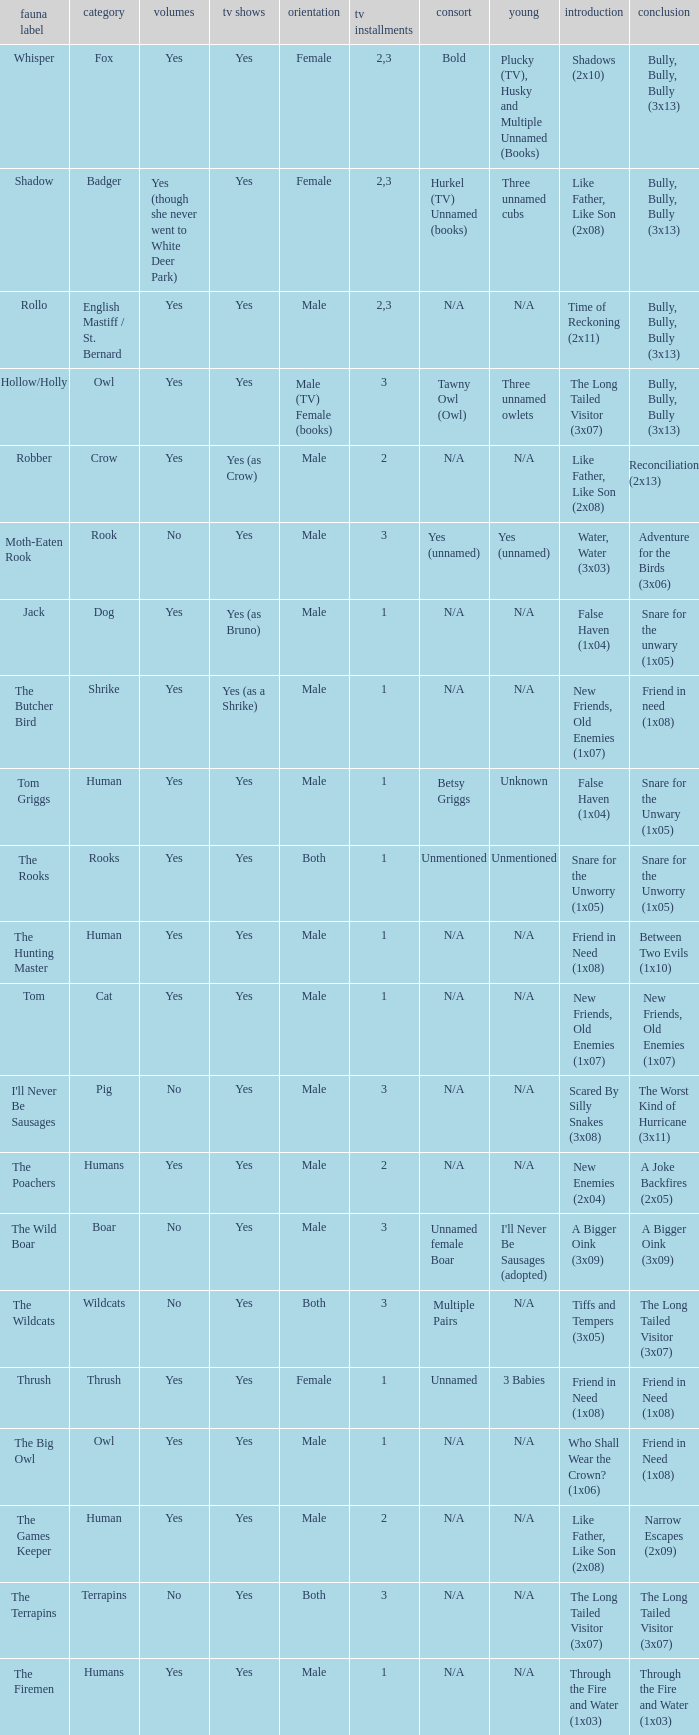What animal was yes for tv series and was a terrapins? The Terrapins. Write the full table. {'header': ['fauna label', 'category', 'volumes', 'tv shows', 'orientation', 'tv installments', 'consort', 'young', 'introduction', 'conclusion'], 'rows': [['Whisper', 'Fox', 'Yes', 'Yes', 'Female', '2,3', 'Bold', 'Plucky (TV), Husky and Multiple Unnamed (Books)', 'Shadows (2x10)', 'Bully, Bully, Bully (3x13)'], ['Shadow', 'Badger', 'Yes (though she never went to White Deer Park)', 'Yes', 'Female', '2,3', 'Hurkel (TV) Unnamed (books)', 'Three unnamed cubs', 'Like Father, Like Son (2x08)', 'Bully, Bully, Bully (3x13)'], ['Rollo', 'English Mastiff / St. Bernard', 'Yes', 'Yes', 'Male', '2,3', 'N/A', 'N/A', 'Time of Reckoning (2x11)', 'Bully, Bully, Bully (3x13)'], ['Hollow/Holly', 'Owl', 'Yes', 'Yes', 'Male (TV) Female (books)', '3', 'Tawny Owl (Owl)', 'Three unnamed owlets', 'The Long Tailed Visitor (3x07)', 'Bully, Bully, Bully (3x13)'], ['Robber', 'Crow', 'Yes', 'Yes (as Crow)', 'Male', '2', 'N/A', 'N/A', 'Like Father, Like Son (2x08)', 'Reconciliation (2x13)'], ['Moth-Eaten Rook', 'Rook', 'No', 'Yes', 'Male', '3', 'Yes (unnamed)', 'Yes (unnamed)', 'Water, Water (3x03)', 'Adventure for the Birds (3x06)'], ['Jack', 'Dog', 'Yes', 'Yes (as Bruno)', 'Male', '1', 'N/A', 'N/A', 'False Haven (1x04)', 'Snare for the unwary (1x05)'], ['The Butcher Bird', 'Shrike', 'Yes', 'Yes (as a Shrike)', 'Male', '1', 'N/A', 'N/A', 'New Friends, Old Enemies (1x07)', 'Friend in need (1x08)'], ['Tom Griggs', 'Human', 'Yes', 'Yes', 'Male', '1', 'Betsy Griggs', 'Unknown', 'False Haven (1x04)', 'Snare for the Unwary (1x05)'], ['The Rooks', 'Rooks', 'Yes', 'Yes', 'Both', '1', 'Unmentioned', 'Unmentioned', 'Snare for the Unworry (1x05)', 'Snare for the Unworry (1x05)'], ['The Hunting Master', 'Human', 'Yes', 'Yes', 'Male', '1', 'N/A', 'N/A', 'Friend in Need (1x08)', 'Between Two Evils (1x10)'], ['Tom', 'Cat', 'Yes', 'Yes', 'Male', '1', 'N/A', 'N/A', 'New Friends, Old Enemies (1x07)', 'New Friends, Old Enemies (1x07)'], ["I'll Never Be Sausages", 'Pig', 'No', 'Yes', 'Male', '3', 'N/A', 'N/A', 'Scared By Silly Snakes (3x08)', 'The Worst Kind of Hurricane (3x11)'], ['The Poachers', 'Humans', 'Yes', 'Yes', 'Male', '2', 'N/A', 'N/A', 'New Enemies (2x04)', 'A Joke Backfires (2x05)'], ['The Wild Boar', 'Boar', 'No', 'Yes', 'Male', '3', 'Unnamed female Boar', "I'll Never Be Sausages (adopted)", 'A Bigger Oink (3x09)', 'A Bigger Oink (3x09)'], ['The Wildcats', 'Wildcats', 'No', 'Yes', 'Both', '3', 'Multiple Pairs', 'N/A', 'Tiffs and Tempers (3x05)', 'The Long Tailed Visitor (3x07)'], ['Thrush', 'Thrush', 'Yes', 'Yes', 'Female', '1', 'Unnamed', '3 Babies', 'Friend in Need (1x08)', 'Friend in Need (1x08)'], ['The Big Owl', 'Owl', 'Yes', 'Yes', 'Male', '1', 'N/A', 'N/A', 'Who Shall Wear the Crown? (1x06)', 'Friend in Need (1x08)'], ['The Games Keeper', 'Human', 'Yes', 'Yes', 'Male', '2', 'N/A', 'N/A', 'Like Father, Like Son (2x08)', 'Narrow Escapes (2x09)'], ['The Terrapins', 'Terrapins', 'No', 'Yes', 'Both', '3', 'N/A', 'N/A', 'The Long Tailed Visitor (3x07)', 'The Long Tailed Visitor (3x07)'], ['The Firemen', 'Humans', 'Yes', 'Yes', 'Male', '1', 'N/A', 'N/A', 'Through the Fire and Water (1x03)', 'Through the Fire and Water (1x03)']]} 